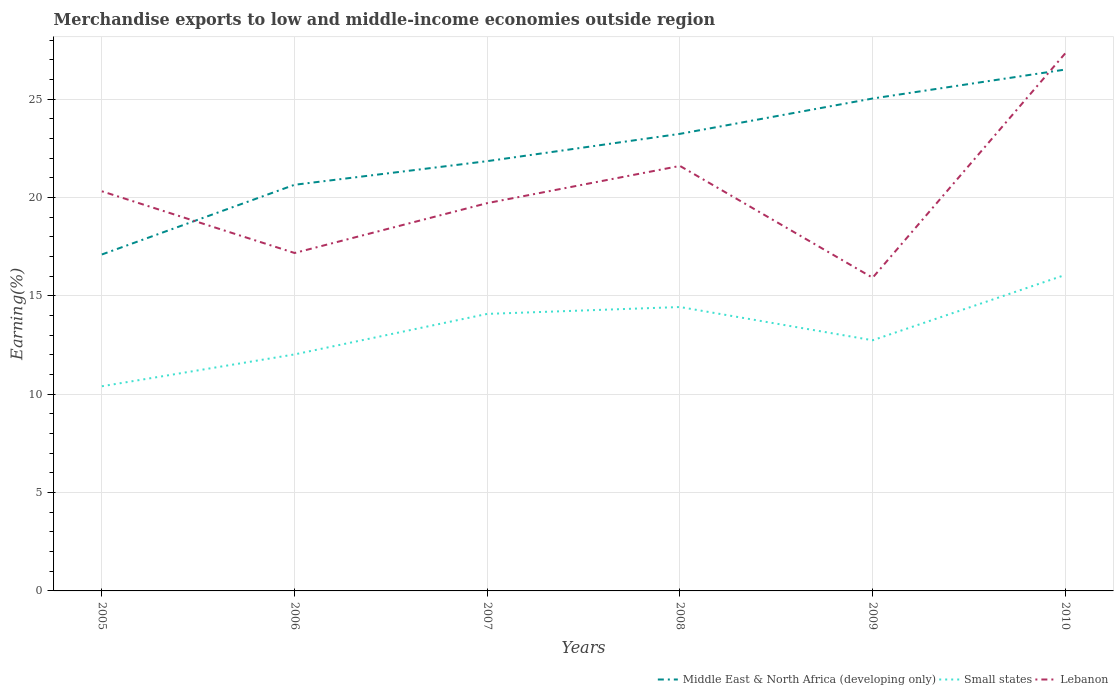How many different coloured lines are there?
Make the answer very short. 3. Is the number of lines equal to the number of legend labels?
Your answer should be compact. Yes. Across all years, what is the maximum percentage of amount earned from merchandise exports in Lebanon?
Ensure brevity in your answer.  15.92. What is the total percentage of amount earned from merchandise exports in Middle East & North Africa (developing only) in the graph?
Offer a terse response. -3.54. What is the difference between the highest and the second highest percentage of amount earned from merchandise exports in Small states?
Your answer should be compact. 5.66. What is the difference between the highest and the lowest percentage of amount earned from merchandise exports in Middle East & North Africa (developing only)?
Offer a terse response. 3. Is the percentage of amount earned from merchandise exports in Lebanon strictly greater than the percentage of amount earned from merchandise exports in Middle East & North Africa (developing only) over the years?
Offer a terse response. No. How many years are there in the graph?
Offer a terse response. 6. What is the difference between two consecutive major ticks on the Y-axis?
Ensure brevity in your answer.  5. Does the graph contain any zero values?
Your answer should be compact. No. Does the graph contain grids?
Make the answer very short. Yes. How are the legend labels stacked?
Ensure brevity in your answer.  Horizontal. What is the title of the graph?
Offer a very short reply. Merchandise exports to low and middle-income economies outside region. Does "Brunei Darussalam" appear as one of the legend labels in the graph?
Ensure brevity in your answer.  No. What is the label or title of the X-axis?
Your answer should be compact. Years. What is the label or title of the Y-axis?
Make the answer very short. Earning(%). What is the Earning(%) in Middle East & North Africa (developing only) in 2005?
Keep it short and to the point. 17.1. What is the Earning(%) of Small states in 2005?
Give a very brief answer. 10.4. What is the Earning(%) in Lebanon in 2005?
Offer a terse response. 20.31. What is the Earning(%) of Middle East & North Africa (developing only) in 2006?
Give a very brief answer. 20.65. What is the Earning(%) in Small states in 2006?
Give a very brief answer. 12.02. What is the Earning(%) in Lebanon in 2006?
Your response must be concise. 17.18. What is the Earning(%) of Middle East & North Africa (developing only) in 2007?
Provide a short and direct response. 21.85. What is the Earning(%) of Small states in 2007?
Make the answer very short. 14.08. What is the Earning(%) of Lebanon in 2007?
Your answer should be compact. 19.71. What is the Earning(%) in Middle East & North Africa (developing only) in 2008?
Your answer should be compact. 23.23. What is the Earning(%) of Small states in 2008?
Provide a short and direct response. 14.43. What is the Earning(%) in Lebanon in 2008?
Your answer should be compact. 21.6. What is the Earning(%) in Middle East & North Africa (developing only) in 2009?
Your response must be concise. 25.03. What is the Earning(%) of Small states in 2009?
Make the answer very short. 12.74. What is the Earning(%) in Lebanon in 2009?
Your answer should be very brief. 15.92. What is the Earning(%) in Middle East & North Africa (developing only) in 2010?
Offer a terse response. 26.5. What is the Earning(%) in Small states in 2010?
Ensure brevity in your answer.  16.07. What is the Earning(%) in Lebanon in 2010?
Offer a terse response. 27.33. Across all years, what is the maximum Earning(%) of Middle East & North Africa (developing only)?
Keep it short and to the point. 26.5. Across all years, what is the maximum Earning(%) in Small states?
Offer a very short reply. 16.07. Across all years, what is the maximum Earning(%) in Lebanon?
Ensure brevity in your answer.  27.33. Across all years, what is the minimum Earning(%) of Middle East & North Africa (developing only)?
Ensure brevity in your answer.  17.1. Across all years, what is the minimum Earning(%) of Small states?
Give a very brief answer. 10.4. Across all years, what is the minimum Earning(%) of Lebanon?
Offer a terse response. 15.92. What is the total Earning(%) in Middle East & North Africa (developing only) in the graph?
Give a very brief answer. 134.36. What is the total Earning(%) of Small states in the graph?
Provide a short and direct response. 79.75. What is the total Earning(%) in Lebanon in the graph?
Provide a succinct answer. 122.06. What is the difference between the Earning(%) in Middle East & North Africa (developing only) in 2005 and that in 2006?
Offer a terse response. -3.54. What is the difference between the Earning(%) in Small states in 2005 and that in 2006?
Your answer should be compact. -1.62. What is the difference between the Earning(%) of Lebanon in 2005 and that in 2006?
Your answer should be very brief. 3.14. What is the difference between the Earning(%) of Middle East & North Africa (developing only) in 2005 and that in 2007?
Offer a terse response. -4.74. What is the difference between the Earning(%) in Small states in 2005 and that in 2007?
Give a very brief answer. -3.68. What is the difference between the Earning(%) of Lebanon in 2005 and that in 2007?
Keep it short and to the point. 0.6. What is the difference between the Earning(%) in Middle East & North Africa (developing only) in 2005 and that in 2008?
Offer a very short reply. -6.13. What is the difference between the Earning(%) of Small states in 2005 and that in 2008?
Ensure brevity in your answer.  -4.03. What is the difference between the Earning(%) of Lebanon in 2005 and that in 2008?
Keep it short and to the point. -1.29. What is the difference between the Earning(%) of Middle East & North Africa (developing only) in 2005 and that in 2009?
Make the answer very short. -7.93. What is the difference between the Earning(%) of Small states in 2005 and that in 2009?
Keep it short and to the point. -2.34. What is the difference between the Earning(%) of Lebanon in 2005 and that in 2009?
Ensure brevity in your answer.  4.4. What is the difference between the Earning(%) in Middle East & North Africa (developing only) in 2005 and that in 2010?
Provide a short and direct response. -9.4. What is the difference between the Earning(%) in Small states in 2005 and that in 2010?
Provide a short and direct response. -5.66. What is the difference between the Earning(%) in Lebanon in 2005 and that in 2010?
Your answer should be compact. -7.02. What is the difference between the Earning(%) of Middle East & North Africa (developing only) in 2006 and that in 2007?
Offer a very short reply. -1.2. What is the difference between the Earning(%) of Small states in 2006 and that in 2007?
Offer a terse response. -2.06. What is the difference between the Earning(%) in Lebanon in 2006 and that in 2007?
Keep it short and to the point. -2.53. What is the difference between the Earning(%) in Middle East & North Africa (developing only) in 2006 and that in 2008?
Provide a succinct answer. -2.59. What is the difference between the Earning(%) of Small states in 2006 and that in 2008?
Ensure brevity in your answer.  -2.41. What is the difference between the Earning(%) of Lebanon in 2006 and that in 2008?
Your answer should be compact. -4.43. What is the difference between the Earning(%) in Middle East & North Africa (developing only) in 2006 and that in 2009?
Ensure brevity in your answer.  -4.39. What is the difference between the Earning(%) of Small states in 2006 and that in 2009?
Give a very brief answer. -0.72. What is the difference between the Earning(%) of Lebanon in 2006 and that in 2009?
Ensure brevity in your answer.  1.26. What is the difference between the Earning(%) in Middle East & North Africa (developing only) in 2006 and that in 2010?
Ensure brevity in your answer.  -5.86. What is the difference between the Earning(%) of Small states in 2006 and that in 2010?
Offer a terse response. -4.04. What is the difference between the Earning(%) in Lebanon in 2006 and that in 2010?
Your answer should be very brief. -10.15. What is the difference between the Earning(%) of Middle East & North Africa (developing only) in 2007 and that in 2008?
Your response must be concise. -1.39. What is the difference between the Earning(%) in Small states in 2007 and that in 2008?
Provide a succinct answer. -0.35. What is the difference between the Earning(%) in Lebanon in 2007 and that in 2008?
Your answer should be compact. -1.89. What is the difference between the Earning(%) of Middle East & North Africa (developing only) in 2007 and that in 2009?
Offer a terse response. -3.18. What is the difference between the Earning(%) in Small states in 2007 and that in 2009?
Offer a very short reply. 1.34. What is the difference between the Earning(%) in Lebanon in 2007 and that in 2009?
Provide a succinct answer. 3.79. What is the difference between the Earning(%) in Middle East & North Africa (developing only) in 2007 and that in 2010?
Your answer should be very brief. -4.66. What is the difference between the Earning(%) in Small states in 2007 and that in 2010?
Ensure brevity in your answer.  -1.98. What is the difference between the Earning(%) of Lebanon in 2007 and that in 2010?
Offer a very short reply. -7.62. What is the difference between the Earning(%) in Middle East & North Africa (developing only) in 2008 and that in 2009?
Provide a succinct answer. -1.8. What is the difference between the Earning(%) of Small states in 2008 and that in 2009?
Ensure brevity in your answer.  1.69. What is the difference between the Earning(%) of Lebanon in 2008 and that in 2009?
Make the answer very short. 5.68. What is the difference between the Earning(%) of Middle East & North Africa (developing only) in 2008 and that in 2010?
Make the answer very short. -3.27. What is the difference between the Earning(%) of Small states in 2008 and that in 2010?
Give a very brief answer. -1.63. What is the difference between the Earning(%) of Lebanon in 2008 and that in 2010?
Provide a succinct answer. -5.73. What is the difference between the Earning(%) in Middle East & North Africa (developing only) in 2009 and that in 2010?
Offer a very short reply. -1.47. What is the difference between the Earning(%) of Small states in 2009 and that in 2010?
Provide a short and direct response. -3.32. What is the difference between the Earning(%) of Lebanon in 2009 and that in 2010?
Give a very brief answer. -11.41. What is the difference between the Earning(%) of Middle East & North Africa (developing only) in 2005 and the Earning(%) of Small states in 2006?
Your response must be concise. 5.08. What is the difference between the Earning(%) in Middle East & North Africa (developing only) in 2005 and the Earning(%) in Lebanon in 2006?
Provide a short and direct response. -0.08. What is the difference between the Earning(%) in Small states in 2005 and the Earning(%) in Lebanon in 2006?
Offer a terse response. -6.77. What is the difference between the Earning(%) of Middle East & North Africa (developing only) in 2005 and the Earning(%) of Small states in 2007?
Give a very brief answer. 3.02. What is the difference between the Earning(%) in Middle East & North Africa (developing only) in 2005 and the Earning(%) in Lebanon in 2007?
Offer a very short reply. -2.61. What is the difference between the Earning(%) in Small states in 2005 and the Earning(%) in Lebanon in 2007?
Provide a short and direct response. -9.31. What is the difference between the Earning(%) in Middle East & North Africa (developing only) in 2005 and the Earning(%) in Small states in 2008?
Provide a succinct answer. 2.67. What is the difference between the Earning(%) in Middle East & North Africa (developing only) in 2005 and the Earning(%) in Lebanon in 2008?
Give a very brief answer. -4.5. What is the difference between the Earning(%) of Small states in 2005 and the Earning(%) of Lebanon in 2008?
Make the answer very short. -11.2. What is the difference between the Earning(%) of Middle East & North Africa (developing only) in 2005 and the Earning(%) of Small states in 2009?
Keep it short and to the point. 4.36. What is the difference between the Earning(%) of Middle East & North Africa (developing only) in 2005 and the Earning(%) of Lebanon in 2009?
Offer a very short reply. 1.18. What is the difference between the Earning(%) of Small states in 2005 and the Earning(%) of Lebanon in 2009?
Your answer should be very brief. -5.52. What is the difference between the Earning(%) in Middle East & North Africa (developing only) in 2005 and the Earning(%) in Small states in 2010?
Provide a short and direct response. 1.04. What is the difference between the Earning(%) in Middle East & North Africa (developing only) in 2005 and the Earning(%) in Lebanon in 2010?
Give a very brief answer. -10.23. What is the difference between the Earning(%) of Small states in 2005 and the Earning(%) of Lebanon in 2010?
Your answer should be very brief. -16.93. What is the difference between the Earning(%) of Middle East & North Africa (developing only) in 2006 and the Earning(%) of Small states in 2007?
Ensure brevity in your answer.  6.56. What is the difference between the Earning(%) in Middle East & North Africa (developing only) in 2006 and the Earning(%) in Lebanon in 2007?
Keep it short and to the point. 0.93. What is the difference between the Earning(%) of Small states in 2006 and the Earning(%) of Lebanon in 2007?
Your answer should be very brief. -7.69. What is the difference between the Earning(%) in Middle East & North Africa (developing only) in 2006 and the Earning(%) in Small states in 2008?
Offer a very short reply. 6.21. What is the difference between the Earning(%) in Middle East & North Africa (developing only) in 2006 and the Earning(%) in Lebanon in 2008?
Keep it short and to the point. -0.96. What is the difference between the Earning(%) of Small states in 2006 and the Earning(%) of Lebanon in 2008?
Ensure brevity in your answer.  -9.58. What is the difference between the Earning(%) in Middle East & North Africa (developing only) in 2006 and the Earning(%) in Small states in 2009?
Offer a very short reply. 7.9. What is the difference between the Earning(%) in Middle East & North Africa (developing only) in 2006 and the Earning(%) in Lebanon in 2009?
Ensure brevity in your answer.  4.73. What is the difference between the Earning(%) in Small states in 2006 and the Earning(%) in Lebanon in 2009?
Make the answer very short. -3.9. What is the difference between the Earning(%) in Middle East & North Africa (developing only) in 2006 and the Earning(%) in Small states in 2010?
Your answer should be compact. 4.58. What is the difference between the Earning(%) in Middle East & North Africa (developing only) in 2006 and the Earning(%) in Lebanon in 2010?
Give a very brief answer. -6.69. What is the difference between the Earning(%) in Small states in 2006 and the Earning(%) in Lebanon in 2010?
Your answer should be compact. -15.31. What is the difference between the Earning(%) in Middle East & North Africa (developing only) in 2007 and the Earning(%) in Small states in 2008?
Provide a succinct answer. 7.42. What is the difference between the Earning(%) in Middle East & North Africa (developing only) in 2007 and the Earning(%) in Lebanon in 2008?
Ensure brevity in your answer.  0.24. What is the difference between the Earning(%) in Small states in 2007 and the Earning(%) in Lebanon in 2008?
Make the answer very short. -7.52. What is the difference between the Earning(%) in Middle East & North Africa (developing only) in 2007 and the Earning(%) in Small states in 2009?
Give a very brief answer. 9.1. What is the difference between the Earning(%) of Middle East & North Africa (developing only) in 2007 and the Earning(%) of Lebanon in 2009?
Make the answer very short. 5.93. What is the difference between the Earning(%) of Small states in 2007 and the Earning(%) of Lebanon in 2009?
Ensure brevity in your answer.  -1.84. What is the difference between the Earning(%) in Middle East & North Africa (developing only) in 2007 and the Earning(%) in Small states in 2010?
Provide a succinct answer. 5.78. What is the difference between the Earning(%) in Middle East & North Africa (developing only) in 2007 and the Earning(%) in Lebanon in 2010?
Your answer should be very brief. -5.49. What is the difference between the Earning(%) of Small states in 2007 and the Earning(%) of Lebanon in 2010?
Keep it short and to the point. -13.25. What is the difference between the Earning(%) of Middle East & North Africa (developing only) in 2008 and the Earning(%) of Small states in 2009?
Your answer should be very brief. 10.49. What is the difference between the Earning(%) of Middle East & North Africa (developing only) in 2008 and the Earning(%) of Lebanon in 2009?
Offer a terse response. 7.31. What is the difference between the Earning(%) in Small states in 2008 and the Earning(%) in Lebanon in 2009?
Provide a succinct answer. -1.49. What is the difference between the Earning(%) in Middle East & North Africa (developing only) in 2008 and the Earning(%) in Small states in 2010?
Keep it short and to the point. 7.17. What is the difference between the Earning(%) of Middle East & North Africa (developing only) in 2008 and the Earning(%) of Lebanon in 2010?
Your answer should be compact. -4.1. What is the difference between the Earning(%) of Small states in 2008 and the Earning(%) of Lebanon in 2010?
Your answer should be compact. -12.9. What is the difference between the Earning(%) in Middle East & North Africa (developing only) in 2009 and the Earning(%) in Small states in 2010?
Offer a terse response. 8.97. What is the difference between the Earning(%) in Middle East & North Africa (developing only) in 2009 and the Earning(%) in Lebanon in 2010?
Make the answer very short. -2.3. What is the difference between the Earning(%) of Small states in 2009 and the Earning(%) of Lebanon in 2010?
Offer a terse response. -14.59. What is the average Earning(%) of Middle East & North Africa (developing only) per year?
Provide a succinct answer. 22.39. What is the average Earning(%) of Small states per year?
Provide a succinct answer. 13.29. What is the average Earning(%) of Lebanon per year?
Your response must be concise. 20.34. In the year 2005, what is the difference between the Earning(%) of Middle East & North Africa (developing only) and Earning(%) of Small states?
Offer a terse response. 6.7. In the year 2005, what is the difference between the Earning(%) of Middle East & North Africa (developing only) and Earning(%) of Lebanon?
Provide a succinct answer. -3.21. In the year 2005, what is the difference between the Earning(%) of Small states and Earning(%) of Lebanon?
Your answer should be compact. -9.91. In the year 2006, what is the difference between the Earning(%) in Middle East & North Africa (developing only) and Earning(%) in Small states?
Your answer should be very brief. 8.62. In the year 2006, what is the difference between the Earning(%) of Middle East & North Africa (developing only) and Earning(%) of Lebanon?
Keep it short and to the point. 3.47. In the year 2006, what is the difference between the Earning(%) of Small states and Earning(%) of Lebanon?
Your answer should be compact. -5.16. In the year 2007, what is the difference between the Earning(%) of Middle East & North Africa (developing only) and Earning(%) of Small states?
Provide a succinct answer. 7.76. In the year 2007, what is the difference between the Earning(%) in Middle East & North Africa (developing only) and Earning(%) in Lebanon?
Your response must be concise. 2.13. In the year 2007, what is the difference between the Earning(%) of Small states and Earning(%) of Lebanon?
Offer a terse response. -5.63. In the year 2008, what is the difference between the Earning(%) of Middle East & North Africa (developing only) and Earning(%) of Small states?
Your response must be concise. 8.8. In the year 2008, what is the difference between the Earning(%) in Middle East & North Africa (developing only) and Earning(%) in Lebanon?
Offer a very short reply. 1.63. In the year 2008, what is the difference between the Earning(%) in Small states and Earning(%) in Lebanon?
Ensure brevity in your answer.  -7.17. In the year 2009, what is the difference between the Earning(%) in Middle East & North Africa (developing only) and Earning(%) in Small states?
Your answer should be very brief. 12.29. In the year 2009, what is the difference between the Earning(%) of Middle East & North Africa (developing only) and Earning(%) of Lebanon?
Keep it short and to the point. 9.11. In the year 2009, what is the difference between the Earning(%) in Small states and Earning(%) in Lebanon?
Give a very brief answer. -3.18. In the year 2010, what is the difference between the Earning(%) in Middle East & North Africa (developing only) and Earning(%) in Small states?
Keep it short and to the point. 10.44. In the year 2010, what is the difference between the Earning(%) in Middle East & North Africa (developing only) and Earning(%) in Lebanon?
Offer a very short reply. -0.83. In the year 2010, what is the difference between the Earning(%) of Small states and Earning(%) of Lebanon?
Your answer should be compact. -11.27. What is the ratio of the Earning(%) of Middle East & North Africa (developing only) in 2005 to that in 2006?
Provide a succinct answer. 0.83. What is the ratio of the Earning(%) of Small states in 2005 to that in 2006?
Your answer should be compact. 0.87. What is the ratio of the Earning(%) in Lebanon in 2005 to that in 2006?
Make the answer very short. 1.18. What is the ratio of the Earning(%) in Middle East & North Africa (developing only) in 2005 to that in 2007?
Provide a succinct answer. 0.78. What is the ratio of the Earning(%) in Small states in 2005 to that in 2007?
Offer a terse response. 0.74. What is the ratio of the Earning(%) of Lebanon in 2005 to that in 2007?
Offer a very short reply. 1.03. What is the ratio of the Earning(%) of Middle East & North Africa (developing only) in 2005 to that in 2008?
Keep it short and to the point. 0.74. What is the ratio of the Earning(%) of Small states in 2005 to that in 2008?
Keep it short and to the point. 0.72. What is the ratio of the Earning(%) in Lebanon in 2005 to that in 2008?
Provide a short and direct response. 0.94. What is the ratio of the Earning(%) of Middle East & North Africa (developing only) in 2005 to that in 2009?
Your answer should be compact. 0.68. What is the ratio of the Earning(%) of Small states in 2005 to that in 2009?
Provide a succinct answer. 0.82. What is the ratio of the Earning(%) in Lebanon in 2005 to that in 2009?
Your answer should be compact. 1.28. What is the ratio of the Earning(%) of Middle East & North Africa (developing only) in 2005 to that in 2010?
Offer a very short reply. 0.65. What is the ratio of the Earning(%) in Small states in 2005 to that in 2010?
Your answer should be very brief. 0.65. What is the ratio of the Earning(%) in Lebanon in 2005 to that in 2010?
Your answer should be compact. 0.74. What is the ratio of the Earning(%) of Middle East & North Africa (developing only) in 2006 to that in 2007?
Your answer should be very brief. 0.94. What is the ratio of the Earning(%) of Small states in 2006 to that in 2007?
Offer a very short reply. 0.85. What is the ratio of the Earning(%) of Lebanon in 2006 to that in 2007?
Offer a very short reply. 0.87. What is the ratio of the Earning(%) in Middle East & North Africa (developing only) in 2006 to that in 2008?
Offer a very short reply. 0.89. What is the ratio of the Earning(%) in Small states in 2006 to that in 2008?
Offer a terse response. 0.83. What is the ratio of the Earning(%) of Lebanon in 2006 to that in 2008?
Provide a succinct answer. 0.8. What is the ratio of the Earning(%) of Middle East & North Africa (developing only) in 2006 to that in 2009?
Offer a very short reply. 0.82. What is the ratio of the Earning(%) in Small states in 2006 to that in 2009?
Provide a short and direct response. 0.94. What is the ratio of the Earning(%) in Lebanon in 2006 to that in 2009?
Ensure brevity in your answer.  1.08. What is the ratio of the Earning(%) of Middle East & North Africa (developing only) in 2006 to that in 2010?
Provide a short and direct response. 0.78. What is the ratio of the Earning(%) in Small states in 2006 to that in 2010?
Your answer should be compact. 0.75. What is the ratio of the Earning(%) of Lebanon in 2006 to that in 2010?
Provide a short and direct response. 0.63. What is the ratio of the Earning(%) of Middle East & North Africa (developing only) in 2007 to that in 2008?
Your answer should be compact. 0.94. What is the ratio of the Earning(%) in Small states in 2007 to that in 2008?
Ensure brevity in your answer.  0.98. What is the ratio of the Earning(%) in Lebanon in 2007 to that in 2008?
Give a very brief answer. 0.91. What is the ratio of the Earning(%) of Middle East & North Africa (developing only) in 2007 to that in 2009?
Offer a terse response. 0.87. What is the ratio of the Earning(%) in Small states in 2007 to that in 2009?
Keep it short and to the point. 1.11. What is the ratio of the Earning(%) in Lebanon in 2007 to that in 2009?
Your answer should be compact. 1.24. What is the ratio of the Earning(%) in Middle East & North Africa (developing only) in 2007 to that in 2010?
Offer a very short reply. 0.82. What is the ratio of the Earning(%) of Small states in 2007 to that in 2010?
Offer a terse response. 0.88. What is the ratio of the Earning(%) of Lebanon in 2007 to that in 2010?
Offer a terse response. 0.72. What is the ratio of the Earning(%) in Middle East & North Africa (developing only) in 2008 to that in 2009?
Offer a terse response. 0.93. What is the ratio of the Earning(%) in Small states in 2008 to that in 2009?
Make the answer very short. 1.13. What is the ratio of the Earning(%) of Lebanon in 2008 to that in 2009?
Your response must be concise. 1.36. What is the ratio of the Earning(%) in Middle East & North Africa (developing only) in 2008 to that in 2010?
Offer a very short reply. 0.88. What is the ratio of the Earning(%) in Small states in 2008 to that in 2010?
Ensure brevity in your answer.  0.9. What is the ratio of the Earning(%) of Lebanon in 2008 to that in 2010?
Offer a terse response. 0.79. What is the ratio of the Earning(%) in Small states in 2009 to that in 2010?
Make the answer very short. 0.79. What is the ratio of the Earning(%) of Lebanon in 2009 to that in 2010?
Keep it short and to the point. 0.58. What is the difference between the highest and the second highest Earning(%) of Middle East & North Africa (developing only)?
Give a very brief answer. 1.47. What is the difference between the highest and the second highest Earning(%) in Small states?
Your response must be concise. 1.63. What is the difference between the highest and the second highest Earning(%) in Lebanon?
Provide a short and direct response. 5.73. What is the difference between the highest and the lowest Earning(%) in Middle East & North Africa (developing only)?
Offer a very short reply. 9.4. What is the difference between the highest and the lowest Earning(%) in Small states?
Your answer should be very brief. 5.66. What is the difference between the highest and the lowest Earning(%) in Lebanon?
Make the answer very short. 11.41. 